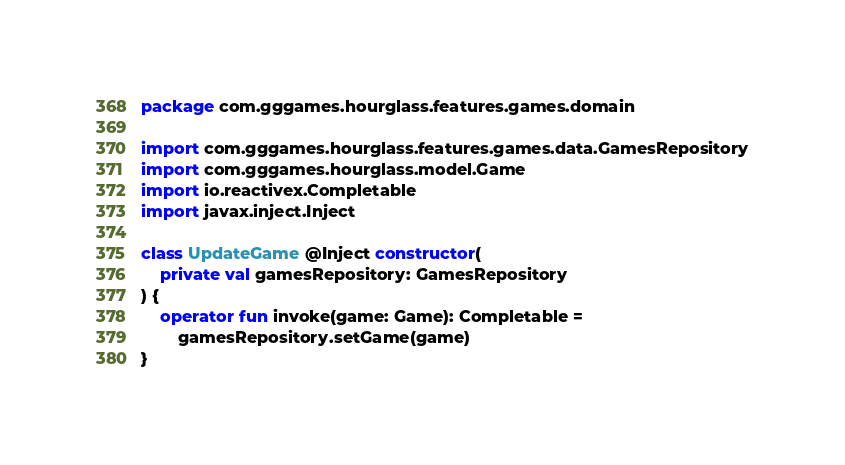<code> <loc_0><loc_0><loc_500><loc_500><_Kotlin_>package com.gggames.hourglass.features.games.domain

import com.gggames.hourglass.features.games.data.GamesRepository
import com.gggames.hourglass.model.Game
import io.reactivex.Completable
import javax.inject.Inject

class UpdateGame @Inject constructor(
    private val gamesRepository: GamesRepository
) {
    operator fun invoke(game: Game): Completable =
        gamesRepository.setGame(game)
}
</code> 